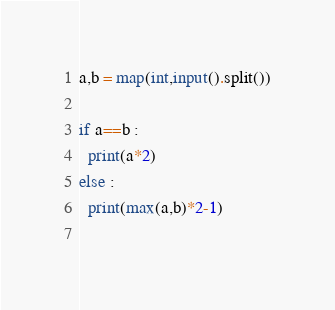<code> <loc_0><loc_0><loc_500><loc_500><_Python_>a,b = map(int,input().split())

if a==b : 
  print(a*2)
else :
  print(max(a,b)*2-1)
    </code> 